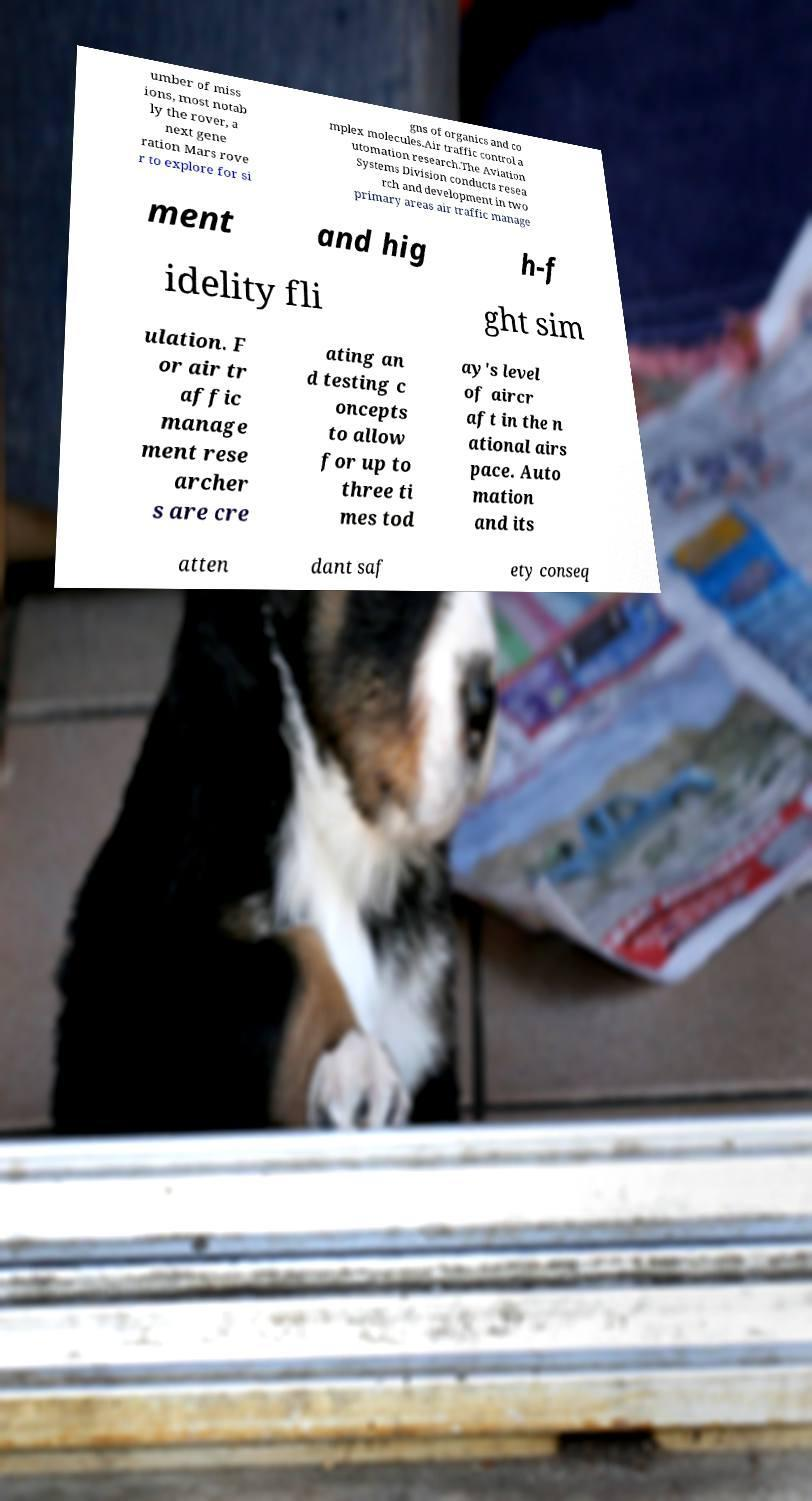I need the written content from this picture converted into text. Can you do that? umber of miss ions, most notab ly the rover, a next gene ration Mars rove r to explore for si gns of organics and co mplex molecules.Air traffic control a utomation research.The Aviation Systems Division conducts resea rch and development in two primary areas air traffic manage ment and hig h-f idelity fli ght sim ulation. F or air tr affic manage ment rese archer s are cre ating an d testing c oncepts to allow for up to three ti mes tod ay's level of aircr aft in the n ational airs pace. Auto mation and its atten dant saf ety conseq 